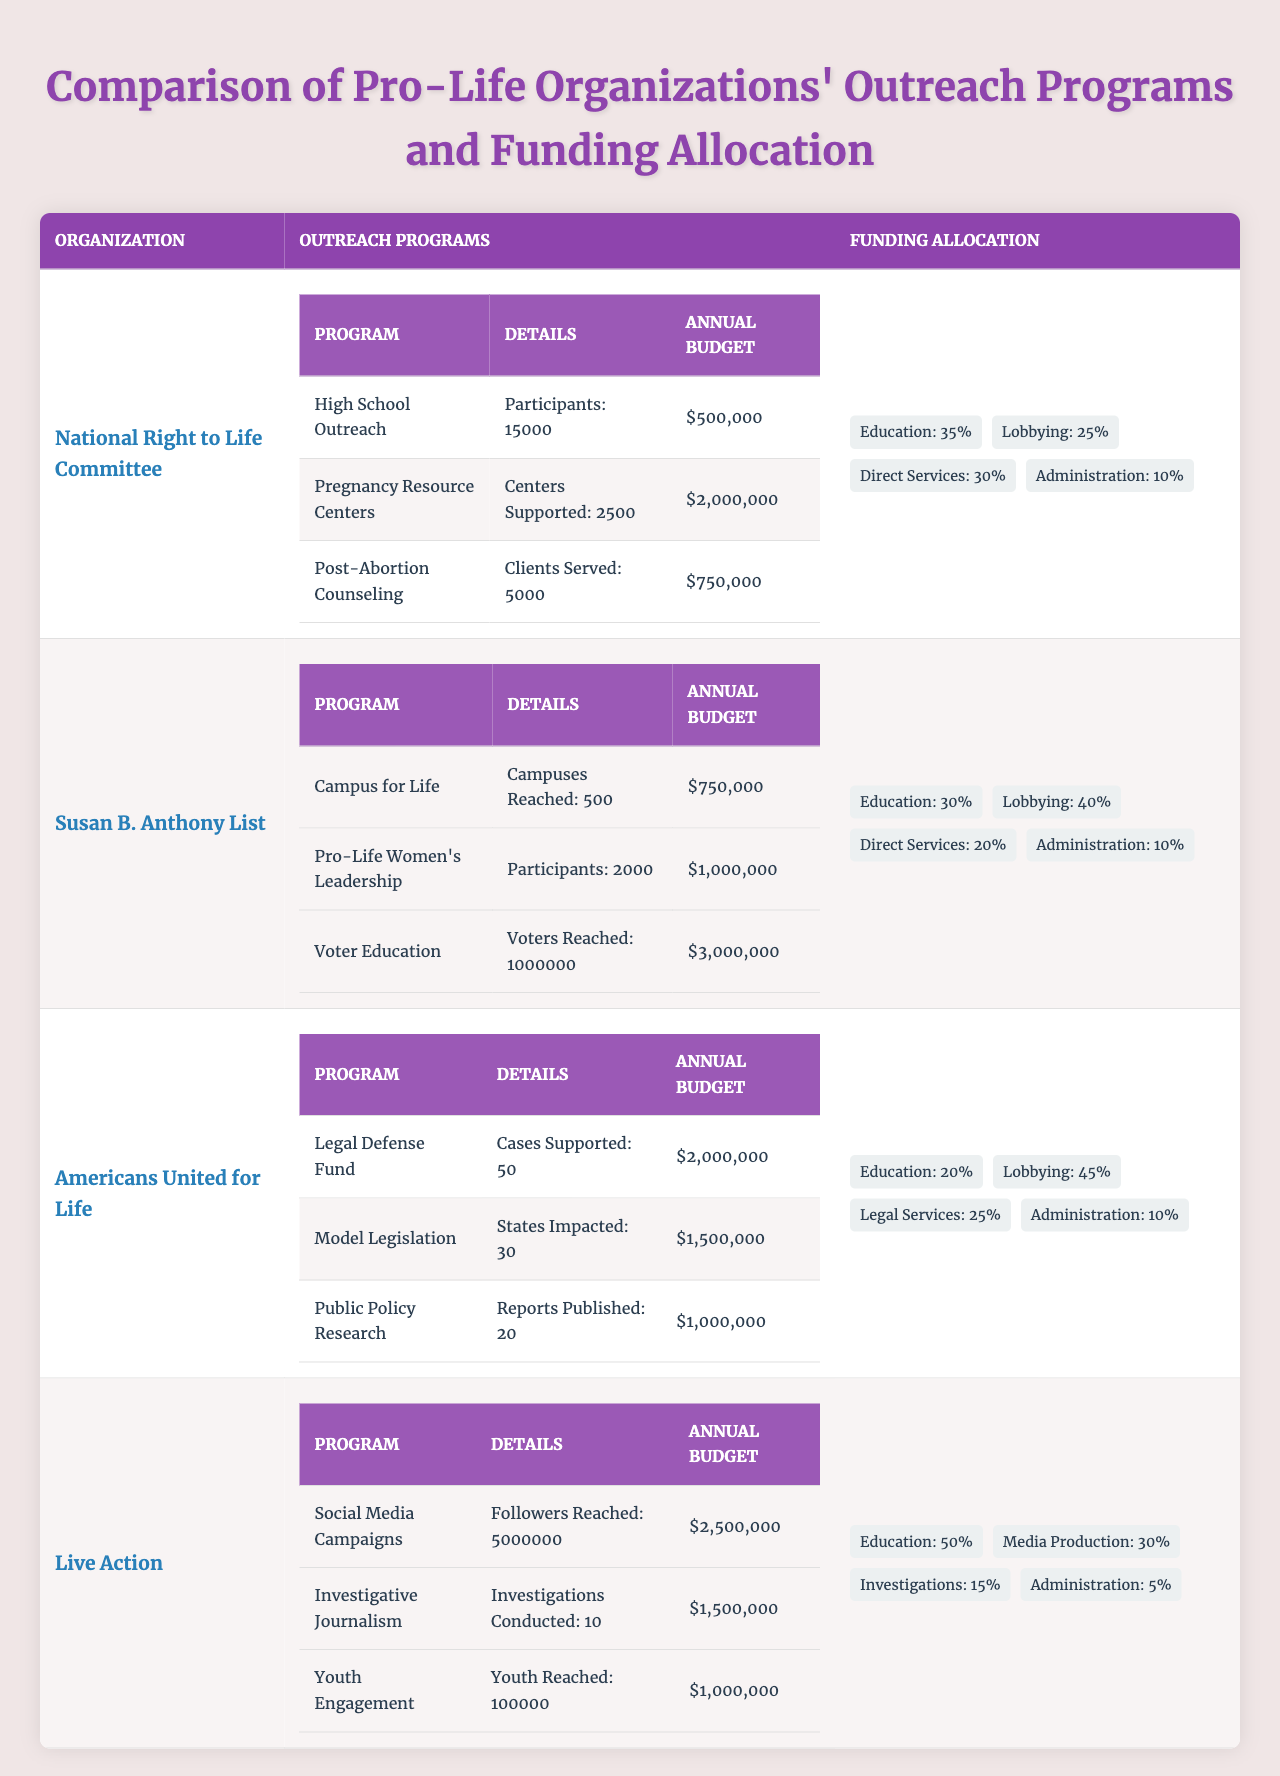What is the annual budget for the "Youth Engagement" program of Live Action? The "Youth Engagement" program's annual budget is listed as $1,000,000 in the outreach programs for Live Action.
Answer: $1,000,000 Which organization has the highest annual budget allocation for their outreach programs? The "Voter Education" program from Susan B. Anthony List has the highest annual budget at $3,000,000.
Answer: Susan B. Anthony List What percentage of funding does Americans United for Life allocate to lobbying? The table shows that Americans United for Life allocates 45% of its funding to lobbying.
Answer: 45% How many total participants are involved in outreach programs offered by the National Right to Life Committee? By adding the participants from various programs: 15,000 (High School Outreach) + 5,000 (Post-Abortion Counseling) gives a total of 20,000 participants.
Answer: 20,000 Which organization's outreach programs reach the largest number of individuals? Live Action reaches the largest audience by having social media campaigns that reach 5,000,000 followers.
Answer: Live Action What is the total amount allocated for education across all organizations? The total allocation for education can be calculated as follows: National Right to Life Committee (35%) + Susan B. Anthony List (30%) + Americans United for Life (20%) + Live Action (50%). To make the total education allocation calculated: 35% + 30% + 20% + 50% = 135%, indicating that on average, organizations focus substantially on education.
Answer: 135% Is it true that Live Action allocates more than half of its budget to education? Yes, Live Action allocates 50% of its funding to education, which is exactly half, not more. Thus, the statement holds true, considering it focuses heavily on educational outreach within its funding distribution.
Answer: Yes Which two organizations have similar percentages for their funding allocation towards administration? Both National Right to Life Committee and Susan B. Anthony List allocate 10% of their funding towards administration, showing that there is alignment in this aspect between the two organizations.
Answer: National Right to Life Committee and Susan B. Anthony List How much more does the "Voter Education" program’s budget surpass that of the "High School Outreach" program? The budget for Voter Education is $3,000,000 while High School Outreach has a budget of $500,000. The difference is $3,000,000 - $500,000 = $2,500,000, indicating a significant focus on voter education over high school outreach.
Answer: $2,500,000 Can you list the organization that spends the least on direct services? The organization that spends the least on direct services is Susan B. Anthony List, which allocates 20% of its funding toward direct services as seen from the funding allocation.
Answer: Susan B. Anthony List What is the total budget for the outreach programs of Americans United for Life? The total budget for all outreach programs of Americans United for Life is $2,000,000 (Legal Defense Fund) + $1,500,000 (Model Legislation) + $1,000,000 (Public Policy Research) = $4,500,000, indicating a robust investment in their outreach initiatives.
Answer: $4,500,000 